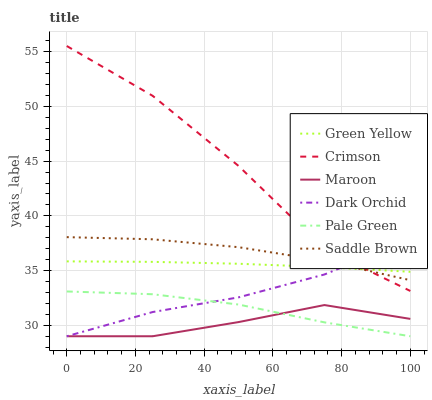Does Maroon have the minimum area under the curve?
Answer yes or no. Yes. Does Crimson have the maximum area under the curve?
Answer yes or no. Yes. Does Pale Green have the minimum area under the curve?
Answer yes or no. No. Does Pale Green have the maximum area under the curve?
Answer yes or no. No. Is Green Yellow the smoothest?
Answer yes or no. Yes. Is Crimson the roughest?
Answer yes or no. Yes. Is Pale Green the smoothest?
Answer yes or no. No. Is Pale Green the roughest?
Answer yes or no. No. Does Dark Orchid have the lowest value?
Answer yes or no. Yes. Does Crimson have the lowest value?
Answer yes or no. No. Does Crimson have the highest value?
Answer yes or no. Yes. Does Pale Green have the highest value?
Answer yes or no. No. Is Maroon less than Crimson?
Answer yes or no. Yes. Is Green Yellow greater than Maroon?
Answer yes or no. Yes. Does Dark Orchid intersect Maroon?
Answer yes or no. Yes. Is Dark Orchid less than Maroon?
Answer yes or no. No. Is Dark Orchid greater than Maroon?
Answer yes or no. No. Does Maroon intersect Crimson?
Answer yes or no. No. 